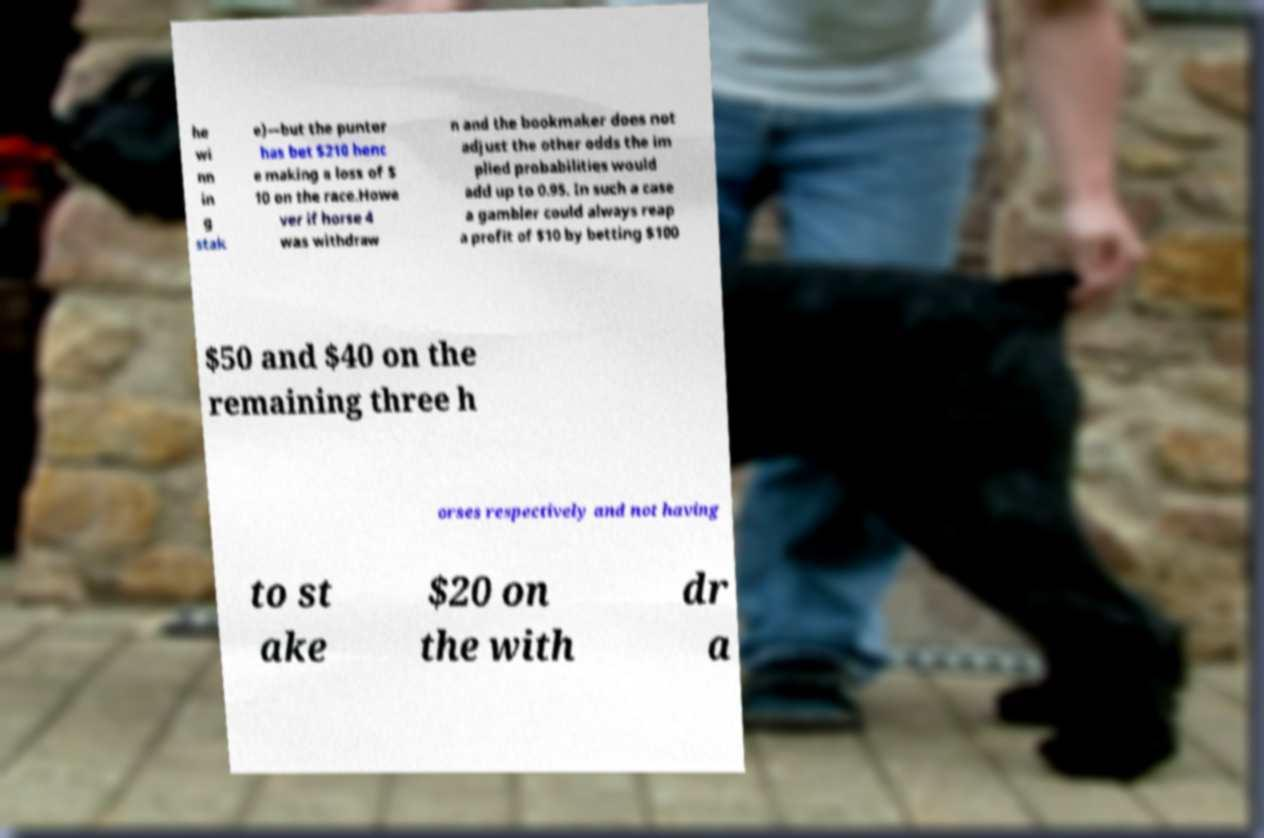Can you accurately transcribe the text from the provided image for me? he wi nn in g stak e)—but the punter has bet $210 henc e making a loss of $ 10 on the race.Howe ver if horse 4 was withdraw n and the bookmaker does not adjust the other odds the im plied probabilities would add up to 0.95. In such a case a gambler could always reap a profit of $10 by betting $100 $50 and $40 on the remaining three h orses respectively and not having to st ake $20 on the with dr a 